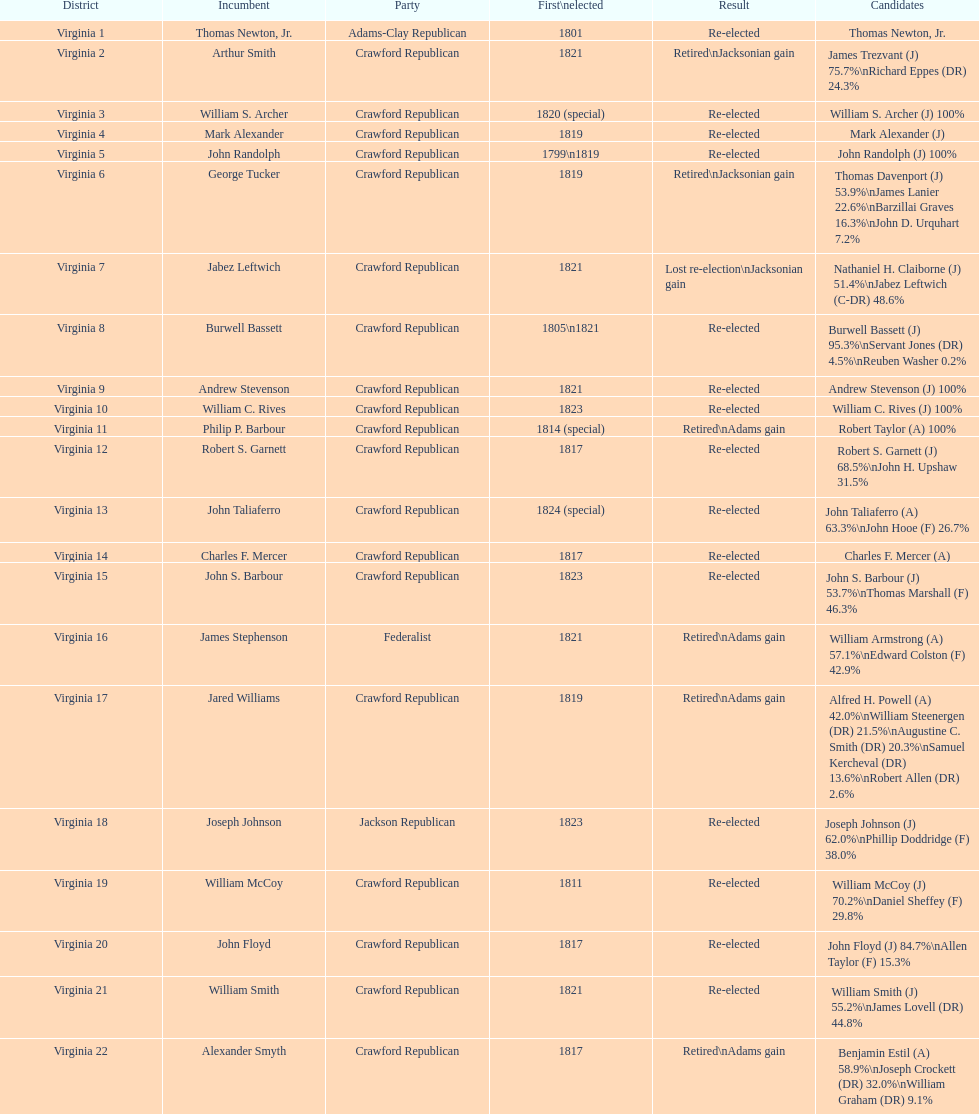What is the final party on this diagram? Crawford Republican. 